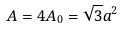Convert formula to latex. <formula><loc_0><loc_0><loc_500><loc_500>A = 4 A _ { 0 } = \sqrt { 3 } a ^ { 2 }</formula> 